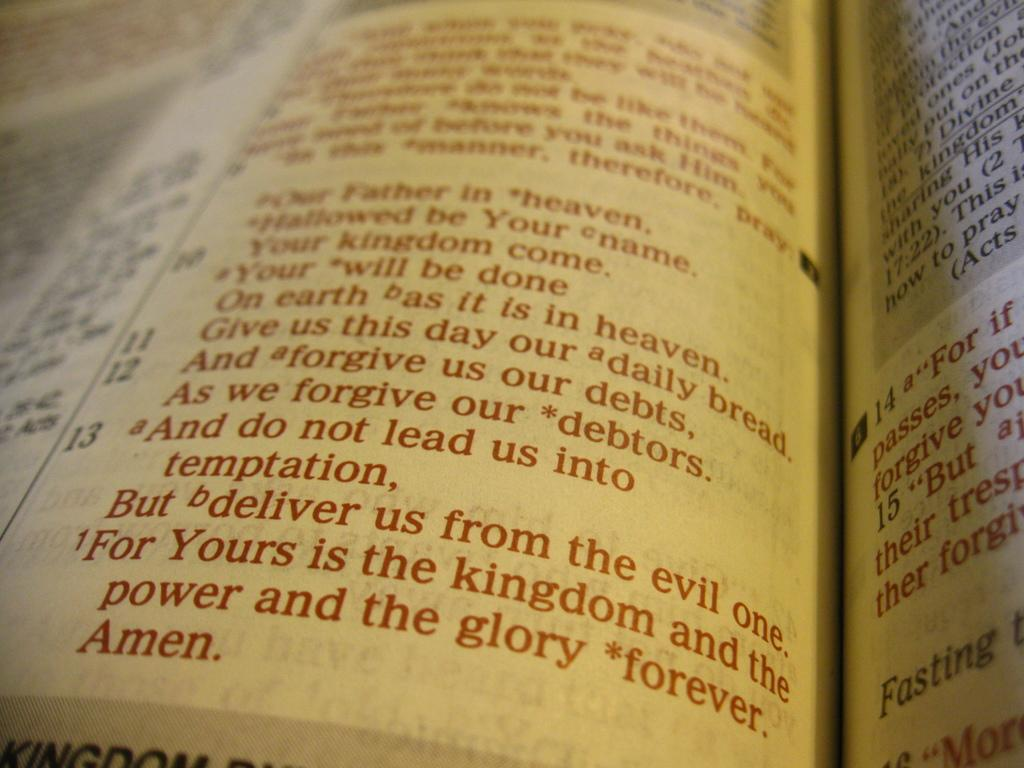<image>
Relay a brief, clear account of the picture shown. A page of the bible shows the word "Amen" at the bottom. 